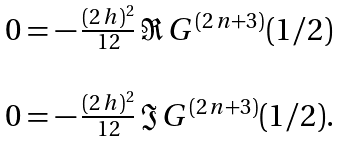<formula> <loc_0><loc_0><loc_500><loc_500>\begin{array} { l } 0 = - \, \frac { ( 2 \, h ) ^ { 2 } } { 1 2 } \, \Re \, G ^ { ( 2 \, n + 3 ) } ( 1 / 2 ) \\ \\ 0 = - \, \frac { ( 2 \, h ) ^ { 2 } } { 1 2 } \, \Im \, G ^ { ( 2 \, n + 3 ) } ( 1 / 2 ) . \end{array}</formula> 